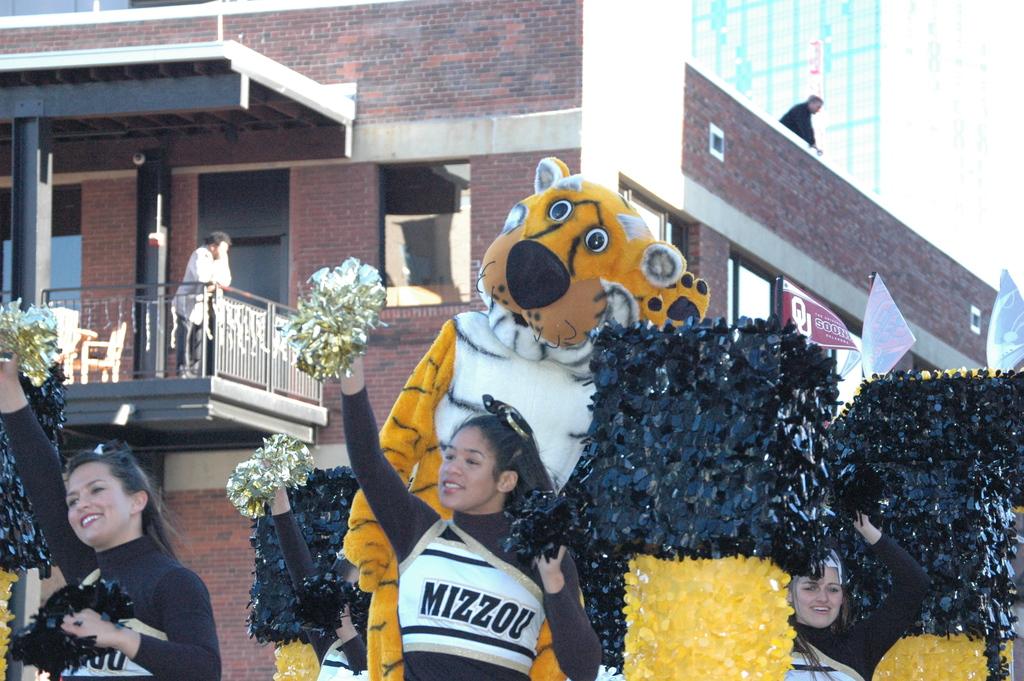What does the cheerleaders uniform say?
Keep it short and to the point. Mizzou. 